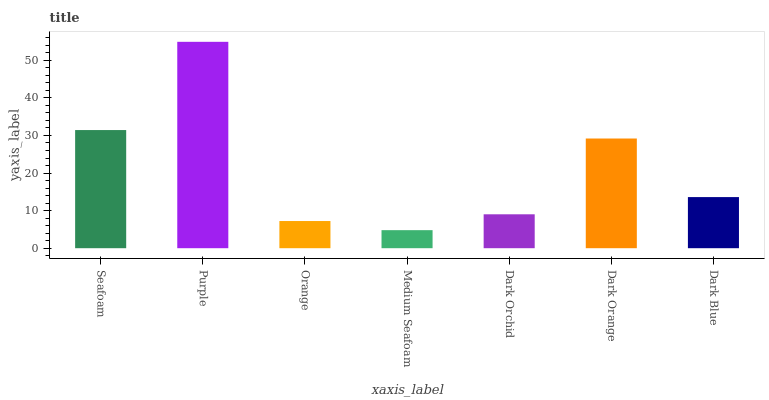Is Medium Seafoam the minimum?
Answer yes or no. Yes. Is Purple the maximum?
Answer yes or no. Yes. Is Orange the minimum?
Answer yes or no. No. Is Orange the maximum?
Answer yes or no. No. Is Purple greater than Orange?
Answer yes or no. Yes. Is Orange less than Purple?
Answer yes or no. Yes. Is Orange greater than Purple?
Answer yes or no. No. Is Purple less than Orange?
Answer yes or no. No. Is Dark Blue the high median?
Answer yes or no. Yes. Is Dark Blue the low median?
Answer yes or no. Yes. Is Orange the high median?
Answer yes or no. No. Is Purple the low median?
Answer yes or no. No. 